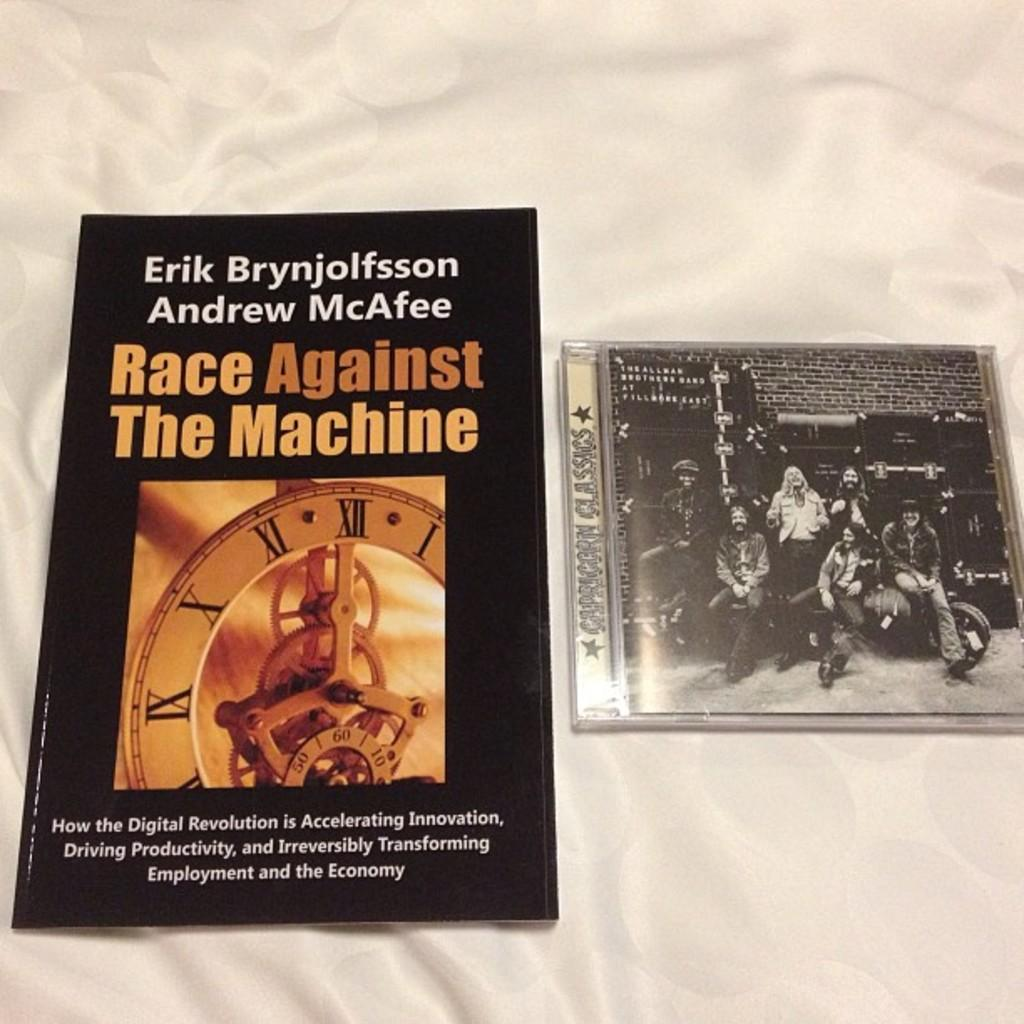<image>
Present a compact description of the photo's key features. A book is next to an Allman Brothers Band CD. 